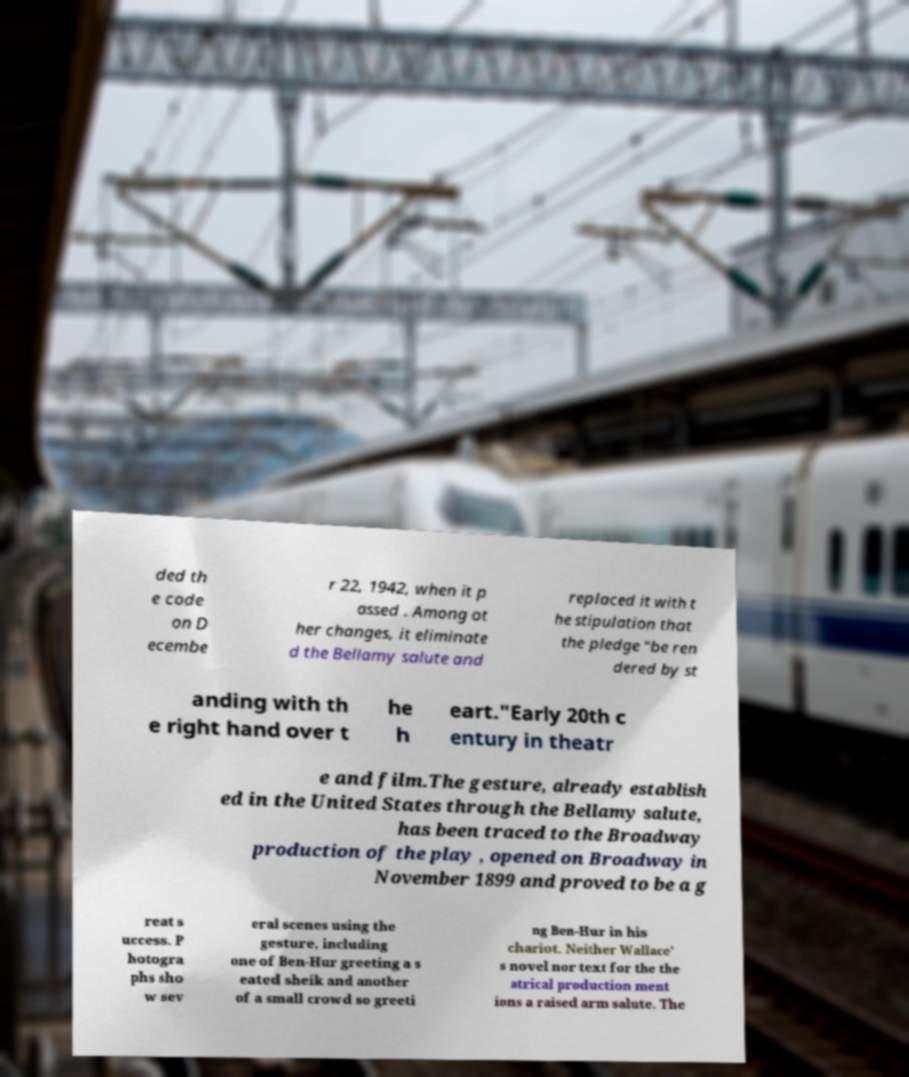Could you extract and type out the text from this image? ded th e code on D ecembe r 22, 1942, when it p assed . Among ot her changes, it eliminate d the Bellamy salute and replaced it with t he stipulation that the pledge "be ren dered by st anding with th e right hand over t he h eart."Early 20th c entury in theatr e and film.The gesture, already establish ed in the United States through the Bellamy salute, has been traced to the Broadway production of the play , opened on Broadway in November 1899 and proved to be a g reat s uccess. P hotogra phs sho w sev eral scenes using the gesture, including one of Ben-Hur greeting a s eated sheik and another of a small crowd so greeti ng Ben-Hur in his chariot. Neither Wallace' s novel nor text for the the atrical production ment ions a raised arm salute. The 